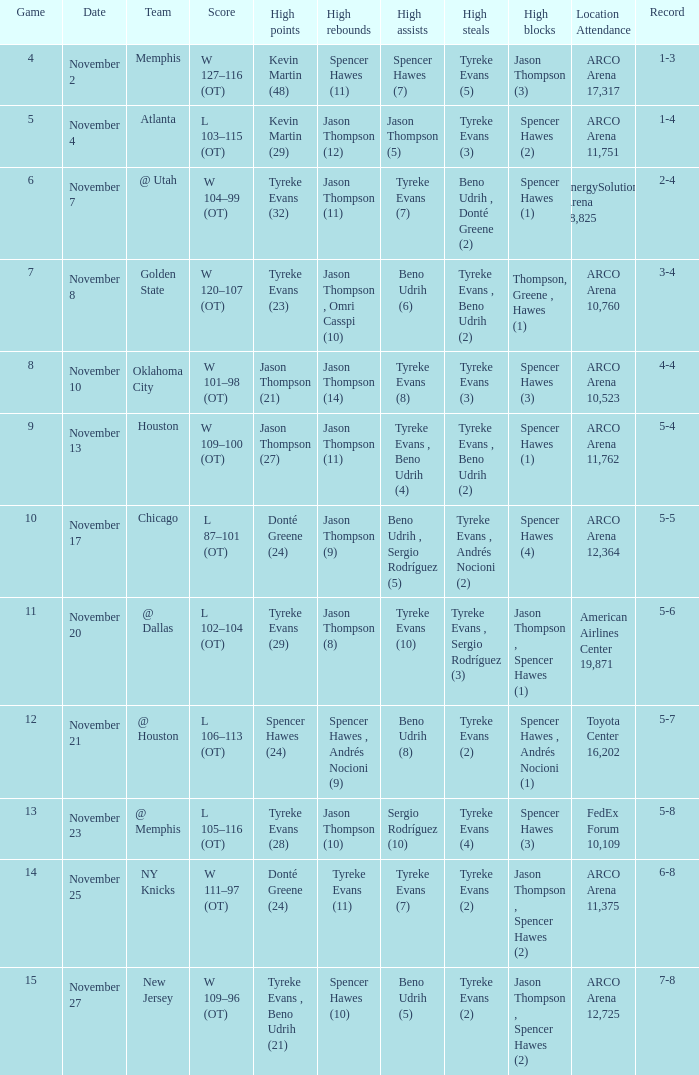If the record is 5-8, what is the team name? @ Memphis. 